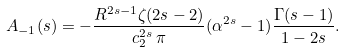<formula> <loc_0><loc_0><loc_500><loc_500>A _ { - 1 } ( s ) = - \frac { R ^ { 2 s - 1 } \zeta ( 2 s - 2 ) } { c _ { 2 } ^ { 2 s } \, \pi } ( \alpha ^ { 2 s } - 1 ) \frac { \Gamma ( s - 1 ) } { 1 - 2 s } .</formula> 